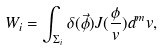<formula> <loc_0><loc_0><loc_500><loc_500>W _ { i } = \int _ { \Sigma _ { i } } \delta ( \vec { \phi } ) J ( \frac { \phi } { v } ) d ^ { m } v ,</formula> 